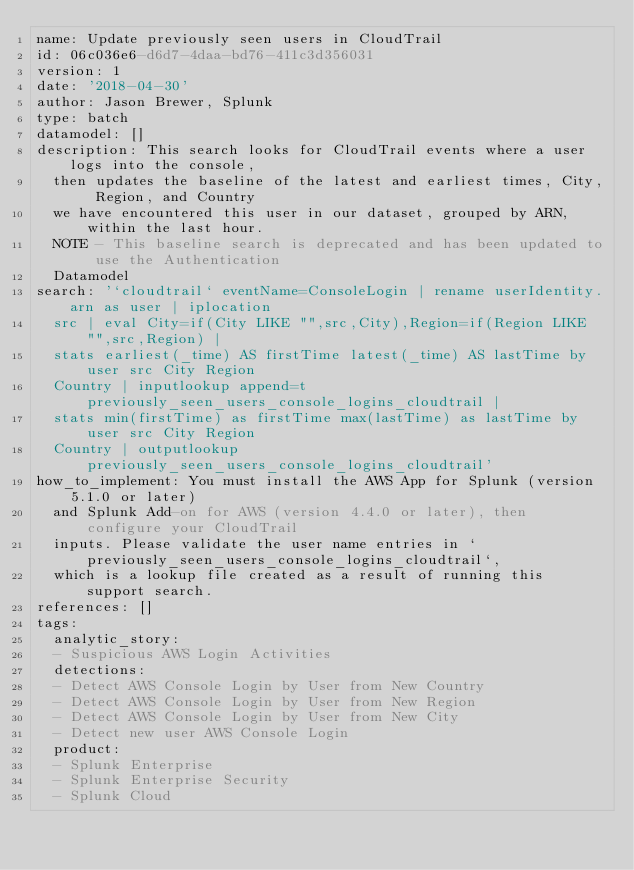Convert code to text. <code><loc_0><loc_0><loc_500><loc_500><_YAML_>name: Update previously seen users in CloudTrail
id: 06c036e6-d6d7-4daa-bd76-411c3d356031
version: 1
date: '2018-04-30'
author: Jason Brewer, Splunk
type: batch
datamodel: []
description: This search looks for CloudTrail events where a user logs into the console,
  then updates the baseline of the latest and earliest times, City, Region, and Country
  we have encountered this user in our dataset, grouped by ARN, within the last hour.
  NOTE - This baseline search is deprecated and has been updated to use the Authentication
  Datamodel
search: '`cloudtrail` eventName=ConsoleLogin | rename userIdentity.arn as user | iplocation
  src | eval City=if(City LIKE "",src,City),Region=if(Region LIKE "",src,Region) |
  stats earliest(_time) AS firstTime latest(_time) AS lastTime by user src City Region
  Country | inputlookup append=t previously_seen_users_console_logins_cloudtrail |
  stats min(firstTime) as firstTime max(lastTime) as lastTime by user src City Region
  Country | outputlookup previously_seen_users_console_logins_cloudtrail'
how_to_implement: You must install the AWS App for Splunk (version 5.1.0 or later)
  and Splunk Add-on for AWS (version 4.4.0 or later), then configure your CloudTrail
  inputs. Please validate the user name entries in `previously_seen_users_console_logins_cloudtrail`,
  which is a lookup file created as a result of running this support search.
references: []
tags:
  analytic_story:
  - Suspicious AWS Login Activities
  detections:
  - Detect AWS Console Login by User from New Country
  - Detect AWS Console Login by User from New Region
  - Detect AWS Console Login by User from New City
  - Detect new user AWS Console Login
  product:
  - Splunk Enterprise
  - Splunk Enterprise Security
  - Splunk Cloud
</code> 